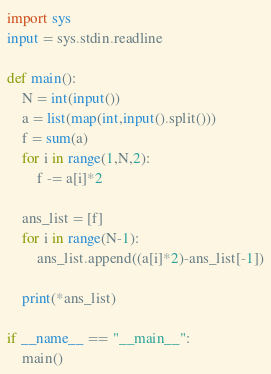Convert code to text. <code><loc_0><loc_0><loc_500><loc_500><_Python_>import sys
input = sys.stdin.readline

def main():
    N = int(input())
    a = list(map(int,input().split()))
    f = sum(a)
    for i in range(1,N,2):
        f -= a[i]*2
    
    ans_list = [f]
    for i in range(N-1):
        ans_list.append((a[i]*2)-ans_list[-1])

    print(*ans_list)

if __name__ == "__main__":
    main()</code> 